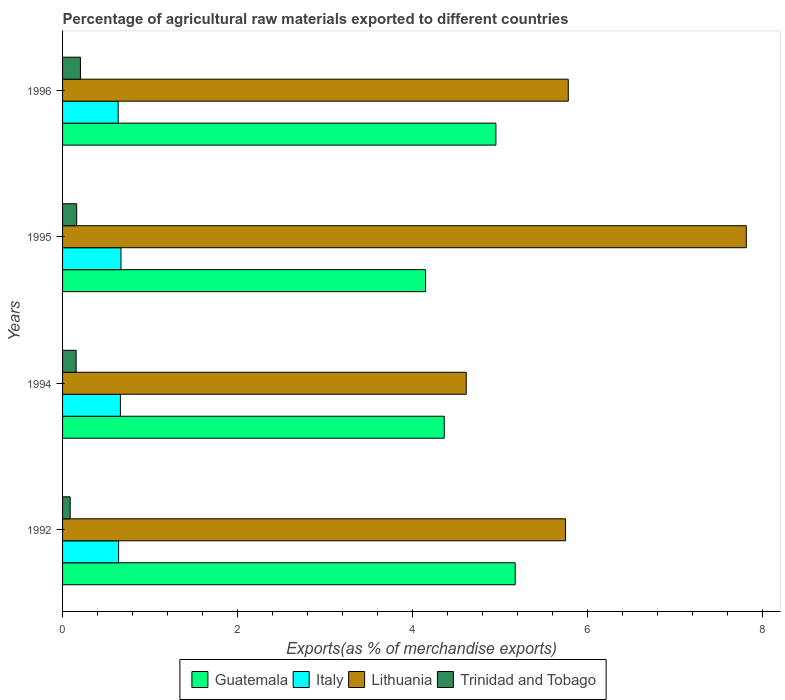How many different coloured bars are there?
Offer a very short reply. 4. How many groups of bars are there?
Your response must be concise. 4. Are the number of bars on each tick of the Y-axis equal?
Keep it short and to the point. Yes. How many bars are there on the 3rd tick from the top?
Keep it short and to the point. 4. What is the percentage of exports to different countries in Trinidad and Tobago in 1995?
Provide a succinct answer. 0.16. Across all years, what is the maximum percentage of exports to different countries in Italy?
Your answer should be very brief. 0.67. Across all years, what is the minimum percentage of exports to different countries in Lithuania?
Make the answer very short. 4.61. In which year was the percentage of exports to different countries in Trinidad and Tobago maximum?
Offer a terse response. 1996. In which year was the percentage of exports to different countries in Lithuania minimum?
Your response must be concise. 1994. What is the total percentage of exports to different countries in Lithuania in the graph?
Your answer should be very brief. 23.95. What is the difference between the percentage of exports to different countries in Trinidad and Tobago in 1992 and that in 1994?
Ensure brevity in your answer.  -0.07. What is the difference between the percentage of exports to different countries in Guatemala in 1992 and the percentage of exports to different countries in Trinidad and Tobago in 1994?
Offer a terse response. 5.02. What is the average percentage of exports to different countries in Trinidad and Tobago per year?
Your answer should be very brief. 0.15. In the year 1994, what is the difference between the percentage of exports to different countries in Trinidad and Tobago and percentage of exports to different countries in Lithuania?
Offer a very short reply. -4.46. In how many years, is the percentage of exports to different countries in Lithuania greater than 1.2000000000000002 %?
Keep it short and to the point. 4. What is the ratio of the percentage of exports to different countries in Lithuania in 1992 to that in 1995?
Keep it short and to the point. 0.74. Is the difference between the percentage of exports to different countries in Trinidad and Tobago in 1992 and 1994 greater than the difference between the percentage of exports to different countries in Lithuania in 1992 and 1994?
Provide a short and direct response. No. What is the difference between the highest and the second highest percentage of exports to different countries in Italy?
Provide a short and direct response. 0.01. What is the difference between the highest and the lowest percentage of exports to different countries in Italy?
Provide a succinct answer. 0.03. What does the 4th bar from the top in 1995 represents?
Provide a succinct answer. Guatemala. What does the 2nd bar from the bottom in 1995 represents?
Your answer should be very brief. Italy. Is it the case that in every year, the sum of the percentage of exports to different countries in Guatemala and percentage of exports to different countries in Trinidad and Tobago is greater than the percentage of exports to different countries in Lithuania?
Your response must be concise. No. How many bars are there?
Your response must be concise. 16. Are all the bars in the graph horizontal?
Offer a very short reply. Yes. What is the difference between two consecutive major ticks on the X-axis?
Keep it short and to the point. 2. Does the graph contain any zero values?
Provide a short and direct response. No. Does the graph contain grids?
Provide a short and direct response. No. Where does the legend appear in the graph?
Your answer should be very brief. Bottom center. How many legend labels are there?
Make the answer very short. 4. What is the title of the graph?
Ensure brevity in your answer.  Percentage of agricultural raw materials exported to different countries. What is the label or title of the X-axis?
Make the answer very short. Exports(as % of merchandise exports). What is the Exports(as % of merchandise exports) in Guatemala in 1992?
Offer a terse response. 5.17. What is the Exports(as % of merchandise exports) of Italy in 1992?
Your response must be concise. 0.64. What is the Exports(as % of merchandise exports) in Lithuania in 1992?
Offer a terse response. 5.75. What is the Exports(as % of merchandise exports) of Trinidad and Tobago in 1992?
Ensure brevity in your answer.  0.09. What is the Exports(as % of merchandise exports) in Guatemala in 1994?
Offer a very short reply. 4.36. What is the Exports(as % of merchandise exports) of Italy in 1994?
Provide a succinct answer. 0.66. What is the Exports(as % of merchandise exports) of Lithuania in 1994?
Give a very brief answer. 4.61. What is the Exports(as % of merchandise exports) of Trinidad and Tobago in 1994?
Ensure brevity in your answer.  0.16. What is the Exports(as % of merchandise exports) in Guatemala in 1995?
Make the answer very short. 4.15. What is the Exports(as % of merchandise exports) in Italy in 1995?
Offer a very short reply. 0.67. What is the Exports(as % of merchandise exports) in Lithuania in 1995?
Provide a succinct answer. 7.81. What is the Exports(as % of merchandise exports) in Trinidad and Tobago in 1995?
Your answer should be very brief. 0.16. What is the Exports(as % of merchandise exports) in Guatemala in 1996?
Provide a succinct answer. 4.95. What is the Exports(as % of merchandise exports) in Italy in 1996?
Your answer should be compact. 0.64. What is the Exports(as % of merchandise exports) of Lithuania in 1996?
Your answer should be compact. 5.78. What is the Exports(as % of merchandise exports) in Trinidad and Tobago in 1996?
Ensure brevity in your answer.  0.2. Across all years, what is the maximum Exports(as % of merchandise exports) in Guatemala?
Keep it short and to the point. 5.17. Across all years, what is the maximum Exports(as % of merchandise exports) of Italy?
Provide a succinct answer. 0.67. Across all years, what is the maximum Exports(as % of merchandise exports) of Lithuania?
Your answer should be compact. 7.81. Across all years, what is the maximum Exports(as % of merchandise exports) of Trinidad and Tobago?
Provide a short and direct response. 0.2. Across all years, what is the minimum Exports(as % of merchandise exports) of Guatemala?
Your answer should be compact. 4.15. Across all years, what is the minimum Exports(as % of merchandise exports) of Italy?
Your answer should be compact. 0.64. Across all years, what is the minimum Exports(as % of merchandise exports) in Lithuania?
Your answer should be compact. 4.61. Across all years, what is the minimum Exports(as % of merchandise exports) of Trinidad and Tobago?
Your answer should be compact. 0.09. What is the total Exports(as % of merchandise exports) of Guatemala in the graph?
Offer a very short reply. 18.64. What is the total Exports(as % of merchandise exports) of Italy in the graph?
Provide a short and direct response. 2.6. What is the total Exports(as % of merchandise exports) of Lithuania in the graph?
Give a very brief answer. 23.95. What is the total Exports(as % of merchandise exports) in Trinidad and Tobago in the graph?
Your answer should be very brief. 0.61. What is the difference between the Exports(as % of merchandise exports) of Guatemala in 1992 and that in 1994?
Your response must be concise. 0.81. What is the difference between the Exports(as % of merchandise exports) in Italy in 1992 and that in 1994?
Your answer should be very brief. -0.02. What is the difference between the Exports(as % of merchandise exports) of Lithuania in 1992 and that in 1994?
Keep it short and to the point. 1.14. What is the difference between the Exports(as % of merchandise exports) in Trinidad and Tobago in 1992 and that in 1994?
Make the answer very short. -0.07. What is the difference between the Exports(as % of merchandise exports) of Guatemala in 1992 and that in 1995?
Ensure brevity in your answer.  1.02. What is the difference between the Exports(as % of merchandise exports) in Italy in 1992 and that in 1995?
Offer a very short reply. -0.03. What is the difference between the Exports(as % of merchandise exports) in Lithuania in 1992 and that in 1995?
Make the answer very short. -2.07. What is the difference between the Exports(as % of merchandise exports) in Trinidad and Tobago in 1992 and that in 1995?
Ensure brevity in your answer.  -0.07. What is the difference between the Exports(as % of merchandise exports) in Guatemala in 1992 and that in 1996?
Provide a short and direct response. 0.22. What is the difference between the Exports(as % of merchandise exports) in Italy in 1992 and that in 1996?
Give a very brief answer. 0.01. What is the difference between the Exports(as % of merchandise exports) of Lithuania in 1992 and that in 1996?
Your response must be concise. -0.03. What is the difference between the Exports(as % of merchandise exports) of Trinidad and Tobago in 1992 and that in 1996?
Keep it short and to the point. -0.12. What is the difference between the Exports(as % of merchandise exports) in Guatemala in 1994 and that in 1995?
Offer a very short reply. 0.21. What is the difference between the Exports(as % of merchandise exports) in Italy in 1994 and that in 1995?
Provide a succinct answer. -0.01. What is the difference between the Exports(as % of merchandise exports) in Lithuania in 1994 and that in 1995?
Provide a short and direct response. -3.2. What is the difference between the Exports(as % of merchandise exports) in Trinidad and Tobago in 1994 and that in 1995?
Your answer should be very brief. -0.01. What is the difference between the Exports(as % of merchandise exports) in Guatemala in 1994 and that in 1996?
Offer a very short reply. -0.59. What is the difference between the Exports(as % of merchandise exports) of Italy in 1994 and that in 1996?
Offer a terse response. 0.03. What is the difference between the Exports(as % of merchandise exports) of Lithuania in 1994 and that in 1996?
Make the answer very short. -1.17. What is the difference between the Exports(as % of merchandise exports) of Trinidad and Tobago in 1994 and that in 1996?
Your answer should be compact. -0.05. What is the difference between the Exports(as % of merchandise exports) in Guatemala in 1995 and that in 1996?
Offer a terse response. -0.8. What is the difference between the Exports(as % of merchandise exports) in Italy in 1995 and that in 1996?
Make the answer very short. 0.03. What is the difference between the Exports(as % of merchandise exports) in Lithuania in 1995 and that in 1996?
Your answer should be very brief. 2.03. What is the difference between the Exports(as % of merchandise exports) in Trinidad and Tobago in 1995 and that in 1996?
Your response must be concise. -0.04. What is the difference between the Exports(as % of merchandise exports) in Guatemala in 1992 and the Exports(as % of merchandise exports) in Italy in 1994?
Give a very brief answer. 4.51. What is the difference between the Exports(as % of merchandise exports) in Guatemala in 1992 and the Exports(as % of merchandise exports) in Lithuania in 1994?
Make the answer very short. 0.56. What is the difference between the Exports(as % of merchandise exports) of Guatemala in 1992 and the Exports(as % of merchandise exports) of Trinidad and Tobago in 1994?
Your response must be concise. 5.02. What is the difference between the Exports(as % of merchandise exports) in Italy in 1992 and the Exports(as % of merchandise exports) in Lithuania in 1994?
Offer a very short reply. -3.97. What is the difference between the Exports(as % of merchandise exports) in Italy in 1992 and the Exports(as % of merchandise exports) in Trinidad and Tobago in 1994?
Keep it short and to the point. 0.49. What is the difference between the Exports(as % of merchandise exports) of Lithuania in 1992 and the Exports(as % of merchandise exports) of Trinidad and Tobago in 1994?
Keep it short and to the point. 5.59. What is the difference between the Exports(as % of merchandise exports) of Guatemala in 1992 and the Exports(as % of merchandise exports) of Italy in 1995?
Offer a very short reply. 4.51. What is the difference between the Exports(as % of merchandise exports) of Guatemala in 1992 and the Exports(as % of merchandise exports) of Lithuania in 1995?
Your answer should be compact. -2.64. What is the difference between the Exports(as % of merchandise exports) in Guatemala in 1992 and the Exports(as % of merchandise exports) in Trinidad and Tobago in 1995?
Ensure brevity in your answer.  5.01. What is the difference between the Exports(as % of merchandise exports) in Italy in 1992 and the Exports(as % of merchandise exports) in Lithuania in 1995?
Offer a very short reply. -7.17. What is the difference between the Exports(as % of merchandise exports) in Italy in 1992 and the Exports(as % of merchandise exports) in Trinidad and Tobago in 1995?
Your response must be concise. 0.48. What is the difference between the Exports(as % of merchandise exports) of Lithuania in 1992 and the Exports(as % of merchandise exports) of Trinidad and Tobago in 1995?
Offer a very short reply. 5.59. What is the difference between the Exports(as % of merchandise exports) in Guatemala in 1992 and the Exports(as % of merchandise exports) in Italy in 1996?
Keep it short and to the point. 4.54. What is the difference between the Exports(as % of merchandise exports) in Guatemala in 1992 and the Exports(as % of merchandise exports) in Lithuania in 1996?
Ensure brevity in your answer.  -0.61. What is the difference between the Exports(as % of merchandise exports) of Guatemala in 1992 and the Exports(as % of merchandise exports) of Trinidad and Tobago in 1996?
Provide a short and direct response. 4.97. What is the difference between the Exports(as % of merchandise exports) of Italy in 1992 and the Exports(as % of merchandise exports) of Lithuania in 1996?
Your answer should be very brief. -5.14. What is the difference between the Exports(as % of merchandise exports) in Italy in 1992 and the Exports(as % of merchandise exports) in Trinidad and Tobago in 1996?
Your response must be concise. 0.44. What is the difference between the Exports(as % of merchandise exports) of Lithuania in 1992 and the Exports(as % of merchandise exports) of Trinidad and Tobago in 1996?
Give a very brief answer. 5.54. What is the difference between the Exports(as % of merchandise exports) of Guatemala in 1994 and the Exports(as % of merchandise exports) of Italy in 1995?
Keep it short and to the point. 3.69. What is the difference between the Exports(as % of merchandise exports) in Guatemala in 1994 and the Exports(as % of merchandise exports) in Lithuania in 1995?
Your answer should be very brief. -3.45. What is the difference between the Exports(as % of merchandise exports) of Guatemala in 1994 and the Exports(as % of merchandise exports) of Trinidad and Tobago in 1995?
Your answer should be very brief. 4.2. What is the difference between the Exports(as % of merchandise exports) in Italy in 1994 and the Exports(as % of merchandise exports) in Lithuania in 1995?
Keep it short and to the point. -7.15. What is the difference between the Exports(as % of merchandise exports) in Italy in 1994 and the Exports(as % of merchandise exports) in Trinidad and Tobago in 1995?
Give a very brief answer. 0.5. What is the difference between the Exports(as % of merchandise exports) in Lithuania in 1994 and the Exports(as % of merchandise exports) in Trinidad and Tobago in 1995?
Your response must be concise. 4.45. What is the difference between the Exports(as % of merchandise exports) of Guatemala in 1994 and the Exports(as % of merchandise exports) of Italy in 1996?
Offer a terse response. 3.73. What is the difference between the Exports(as % of merchandise exports) in Guatemala in 1994 and the Exports(as % of merchandise exports) in Lithuania in 1996?
Your answer should be very brief. -1.42. What is the difference between the Exports(as % of merchandise exports) of Guatemala in 1994 and the Exports(as % of merchandise exports) of Trinidad and Tobago in 1996?
Give a very brief answer. 4.16. What is the difference between the Exports(as % of merchandise exports) of Italy in 1994 and the Exports(as % of merchandise exports) of Lithuania in 1996?
Your answer should be very brief. -5.12. What is the difference between the Exports(as % of merchandise exports) in Italy in 1994 and the Exports(as % of merchandise exports) in Trinidad and Tobago in 1996?
Give a very brief answer. 0.46. What is the difference between the Exports(as % of merchandise exports) of Lithuania in 1994 and the Exports(as % of merchandise exports) of Trinidad and Tobago in 1996?
Make the answer very short. 4.41. What is the difference between the Exports(as % of merchandise exports) in Guatemala in 1995 and the Exports(as % of merchandise exports) in Italy in 1996?
Your answer should be very brief. 3.51. What is the difference between the Exports(as % of merchandise exports) of Guatemala in 1995 and the Exports(as % of merchandise exports) of Lithuania in 1996?
Your answer should be compact. -1.63. What is the difference between the Exports(as % of merchandise exports) of Guatemala in 1995 and the Exports(as % of merchandise exports) of Trinidad and Tobago in 1996?
Your answer should be very brief. 3.94. What is the difference between the Exports(as % of merchandise exports) of Italy in 1995 and the Exports(as % of merchandise exports) of Lithuania in 1996?
Provide a short and direct response. -5.11. What is the difference between the Exports(as % of merchandise exports) in Italy in 1995 and the Exports(as % of merchandise exports) in Trinidad and Tobago in 1996?
Make the answer very short. 0.46. What is the difference between the Exports(as % of merchandise exports) in Lithuania in 1995 and the Exports(as % of merchandise exports) in Trinidad and Tobago in 1996?
Your response must be concise. 7.61. What is the average Exports(as % of merchandise exports) in Guatemala per year?
Your answer should be very brief. 4.66. What is the average Exports(as % of merchandise exports) in Italy per year?
Keep it short and to the point. 0.65. What is the average Exports(as % of merchandise exports) of Lithuania per year?
Offer a very short reply. 5.99. What is the average Exports(as % of merchandise exports) of Trinidad and Tobago per year?
Your answer should be compact. 0.15. In the year 1992, what is the difference between the Exports(as % of merchandise exports) of Guatemala and Exports(as % of merchandise exports) of Italy?
Provide a short and direct response. 4.53. In the year 1992, what is the difference between the Exports(as % of merchandise exports) of Guatemala and Exports(as % of merchandise exports) of Lithuania?
Keep it short and to the point. -0.58. In the year 1992, what is the difference between the Exports(as % of merchandise exports) in Guatemala and Exports(as % of merchandise exports) in Trinidad and Tobago?
Offer a very short reply. 5.09. In the year 1992, what is the difference between the Exports(as % of merchandise exports) in Italy and Exports(as % of merchandise exports) in Lithuania?
Keep it short and to the point. -5.11. In the year 1992, what is the difference between the Exports(as % of merchandise exports) in Italy and Exports(as % of merchandise exports) in Trinidad and Tobago?
Make the answer very short. 0.55. In the year 1992, what is the difference between the Exports(as % of merchandise exports) of Lithuania and Exports(as % of merchandise exports) of Trinidad and Tobago?
Offer a very short reply. 5.66. In the year 1994, what is the difference between the Exports(as % of merchandise exports) of Guatemala and Exports(as % of merchandise exports) of Italy?
Provide a succinct answer. 3.7. In the year 1994, what is the difference between the Exports(as % of merchandise exports) of Guatemala and Exports(as % of merchandise exports) of Lithuania?
Keep it short and to the point. -0.25. In the year 1994, what is the difference between the Exports(as % of merchandise exports) of Guatemala and Exports(as % of merchandise exports) of Trinidad and Tobago?
Offer a very short reply. 4.21. In the year 1994, what is the difference between the Exports(as % of merchandise exports) in Italy and Exports(as % of merchandise exports) in Lithuania?
Your answer should be compact. -3.95. In the year 1994, what is the difference between the Exports(as % of merchandise exports) in Italy and Exports(as % of merchandise exports) in Trinidad and Tobago?
Provide a succinct answer. 0.51. In the year 1994, what is the difference between the Exports(as % of merchandise exports) in Lithuania and Exports(as % of merchandise exports) in Trinidad and Tobago?
Your response must be concise. 4.46. In the year 1995, what is the difference between the Exports(as % of merchandise exports) in Guatemala and Exports(as % of merchandise exports) in Italy?
Provide a succinct answer. 3.48. In the year 1995, what is the difference between the Exports(as % of merchandise exports) of Guatemala and Exports(as % of merchandise exports) of Lithuania?
Keep it short and to the point. -3.67. In the year 1995, what is the difference between the Exports(as % of merchandise exports) in Guatemala and Exports(as % of merchandise exports) in Trinidad and Tobago?
Your answer should be very brief. 3.99. In the year 1995, what is the difference between the Exports(as % of merchandise exports) in Italy and Exports(as % of merchandise exports) in Lithuania?
Ensure brevity in your answer.  -7.15. In the year 1995, what is the difference between the Exports(as % of merchandise exports) of Italy and Exports(as % of merchandise exports) of Trinidad and Tobago?
Ensure brevity in your answer.  0.51. In the year 1995, what is the difference between the Exports(as % of merchandise exports) of Lithuania and Exports(as % of merchandise exports) of Trinidad and Tobago?
Give a very brief answer. 7.65. In the year 1996, what is the difference between the Exports(as % of merchandise exports) of Guatemala and Exports(as % of merchandise exports) of Italy?
Provide a succinct answer. 4.32. In the year 1996, what is the difference between the Exports(as % of merchandise exports) in Guatemala and Exports(as % of merchandise exports) in Lithuania?
Provide a short and direct response. -0.83. In the year 1996, what is the difference between the Exports(as % of merchandise exports) in Guatemala and Exports(as % of merchandise exports) in Trinidad and Tobago?
Ensure brevity in your answer.  4.75. In the year 1996, what is the difference between the Exports(as % of merchandise exports) in Italy and Exports(as % of merchandise exports) in Lithuania?
Offer a terse response. -5.14. In the year 1996, what is the difference between the Exports(as % of merchandise exports) in Italy and Exports(as % of merchandise exports) in Trinidad and Tobago?
Offer a very short reply. 0.43. In the year 1996, what is the difference between the Exports(as % of merchandise exports) in Lithuania and Exports(as % of merchandise exports) in Trinidad and Tobago?
Your response must be concise. 5.58. What is the ratio of the Exports(as % of merchandise exports) of Guatemala in 1992 to that in 1994?
Ensure brevity in your answer.  1.19. What is the ratio of the Exports(as % of merchandise exports) in Italy in 1992 to that in 1994?
Your answer should be compact. 0.97. What is the ratio of the Exports(as % of merchandise exports) of Lithuania in 1992 to that in 1994?
Make the answer very short. 1.25. What is the ratio of the Exports(as % of merchandise exports) in Trinidad and Tobago in 1992 to that in 1994?
Your answer should be very brief. 0.56. What is the ratio of the Exports(as % of merchandise exports) of Guatemala in 1992 to that in 1995?
Make the answer very short. 1.25. What is the ratio of the Exports(as % of merchandise exports) in Italy in 1992 to that in 1995?
Your answer should be very brief. 0.96. What is the ratio of the Exports(as % of merchandise exports) in Lithuania in 1992 to that in 1995?
Keep it short and to the point. 0.74. What is the ratio of the Exports(as % of merchandise exports) of Trinidad and Tobago in 1992 to that in 1995?
Your answer should be very brief. 0.54. What is the ratio of the Exports(as % of merchandise exports) of Guatemala in 1992 to that in 1996?
Your answer should be compact. 1.04. What is the ratio of the Exports(as % of merchandise exports) in Italy in 1992 to that in 1996?
Provide a succinct answer. 1.01. What is the ratio of the Exports(as % of merchandise exports) of Trinidad and Tobago in 1992 to that in 1996?
Your answer should be compact. 0.42. What is the ratio of the Exports(as % of merchandise exports) of Guatemala in 1994 to that in 1995?
Give a very brief answer. 1.05. What is the ratio of the Exports(as % of merchandise exports) of Italy in 1994 to that in 1995?
Offer a terse response. 0.99. What is the ratio of the Exports(as % of merchandise exports) in Lithuania in 1994 to that in 1995?
Provide a succinct answer. 0.59. What is the ratio of the Exports(as % of merchandise exports) of Trinidad and Tobago in 1994 to that in 1995?
Make the answer very short. 0.96. What is the ratio of the Exports(as % of merchandise exports) of Guatemala in 1994 to that in 1996?
Offer a terse response. 0.88. What is the ratio of the Exports(as % of merchandise exports) in Italy in 1994 to that in 1996?
Offer a terse response. 1.04. What is the ratio of the Exports(as % of merchandise exports) in Lithuania in 1994 to that in 1996?
Ensure brevity in your answer.  0.8. What is the ratio of the Exports(as % of merchandise exports) in Trinidad and Tobago in 1994 to that in 1996?
Give a very brief answer. 0.76. What is the ratio of the Exports(as % of merchandise exports) of Guatemala in 1995 to that in 1996?
Make the answer very short. 0.84. What is the ratio of the Exports(as % of merchandise exports) in Italy in 1995 to that in 1996?
Give a very brief answer. 1.05. What is the ratio of the Exports(as % of merchandise exports) of Lithuania in 1995 to that in 1996?
Keep it short and to the point. 1.35. What is the ratio of the Exports(as % of merchandise exports) in Trinidad and Tobago in 1995 to that in 1996?
Keep it short and to the point. 0.79. What is the difference between the highest and the second highest Exports(as % of merchandise exports) in Guatemala?
Your answer should be very brief. 0.22. What is the difference between the highest and the second highest Exports(as % of merchandise exports) of Italy?
Offer a very short reply. 0.01. What is the difference between the highest and the second highest Exports(as % of merchandise exports) of Lithuania?
Offer a terse response. 2.03. What is the difference between the highest and the second highest Exports(as % of merchandise exports) in Trinidad and Tobago?
Offer a very short reply. 0.04. What is the difference between the highest and the lowest Exports(as % of merchandise exports) of Guatemala?
Give a very brief answer. 1.02. What is the difference between the highest and the lowest Exports(as % of merchandise exports) in Italy?
Ensure brevity in your answer.  0.03. What is the difference between the highest and the lowest Exports(as % of merchandise exports) in Lithuania?
Give a very brief answer. 3.2. What is the difference between the highest and the lowest Exports(as % of merchandise exports) in Trinidad and Tobago?
Your answer should be compact. 0.12. 